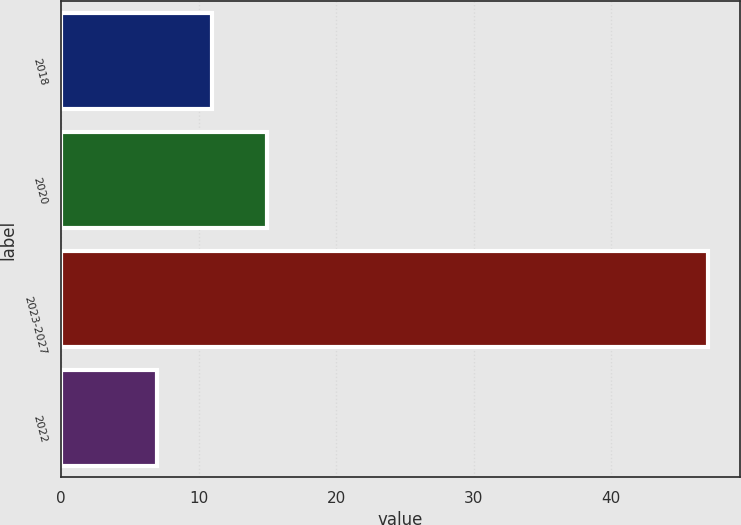<chart> <loc_0><loc_0><loc_500><loc_500><bar_chart><fcel>2018<fcel>2020<fcel>2023-2027<fcel>2022<nl><fcel>11<fcel>15<fcel>47<fcel>7<nl></chart> 